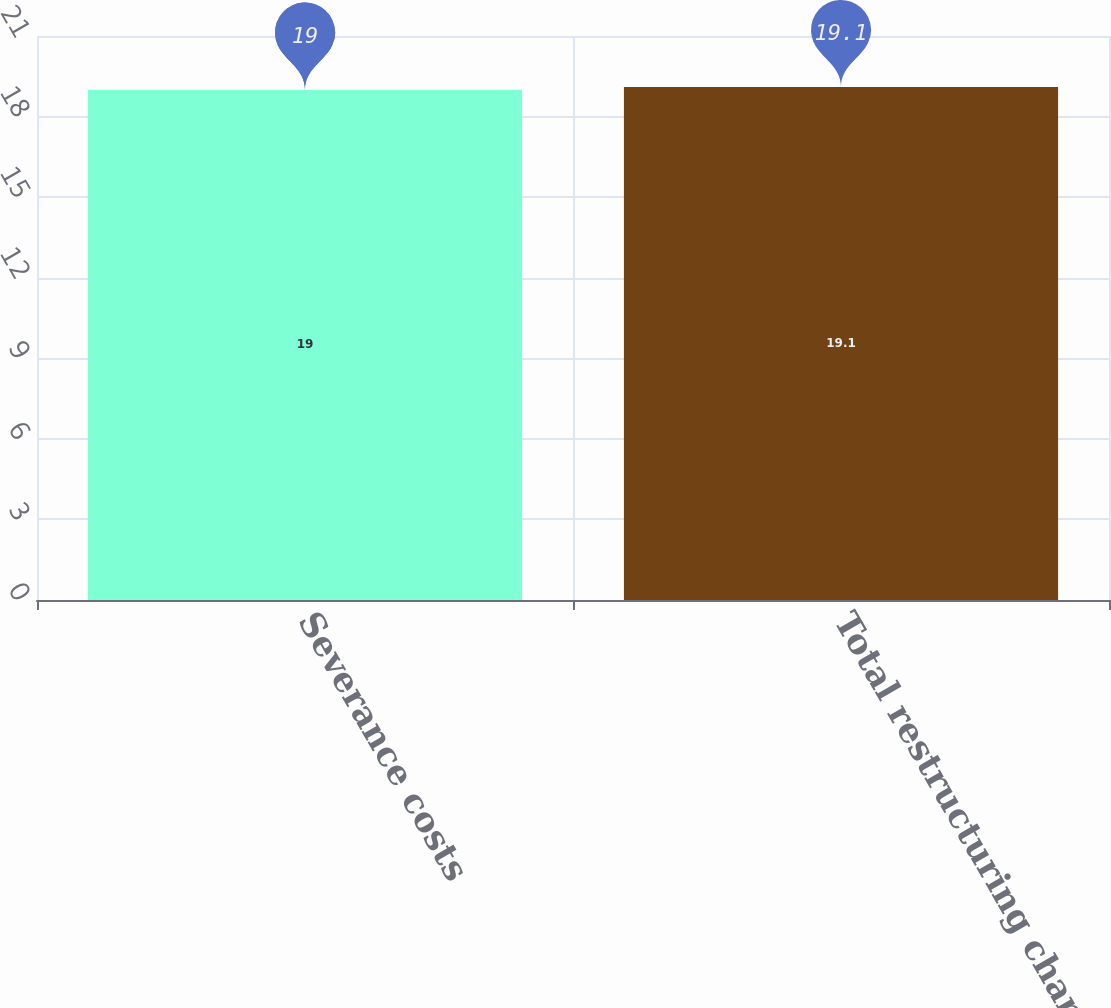<chart> <loc_0><loc_0><loc_500><loc_500><bar_chart><fcel>Severance costs<fcel>Total restructuring charges<nl><fcel>19<fcel>19.1<nl></chart> 